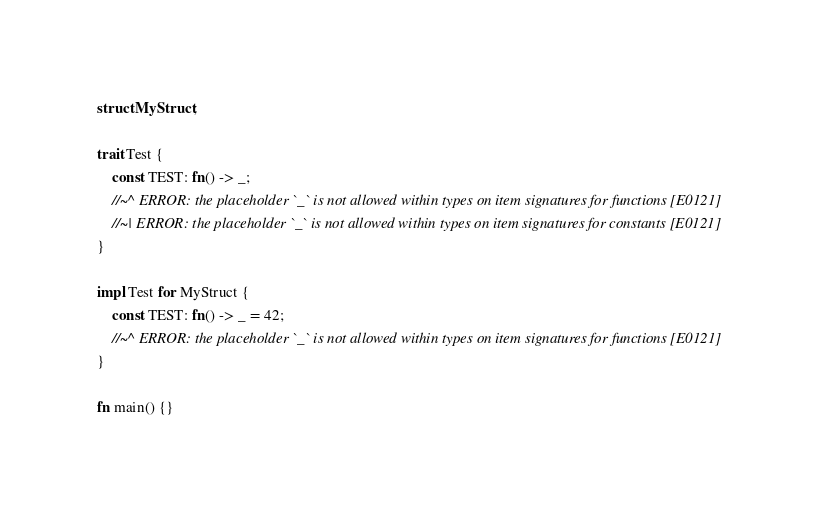<code> <loc_0><loc_0><loc_500><loc_500><_Rust_>struct MyStruct;

trait Test {
    const TEST: fn() -> _;
    //~^ ERROR: the placeholder `_` is not allowed within types on item signatures for functions [E0121]
    //~| ERROR: the placeholder `_` is not allowed within types on item signatures for constants [E0121]
}

impl Test for MyStruct {
    const TEST: fn() -> _ = 42;
    //~^ ERROR: the placeholder `_` is not allowed within types on item signatures for functions [E0121]
}

fn main() {}
</code> 